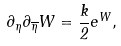<formula> <loc_0><loc_0><loc_500><loc_500>\partial _ { \eta } \partial _ { \overline { \eta } } W = \frac { k } { 2 } e ^ { W } ,</formula> 